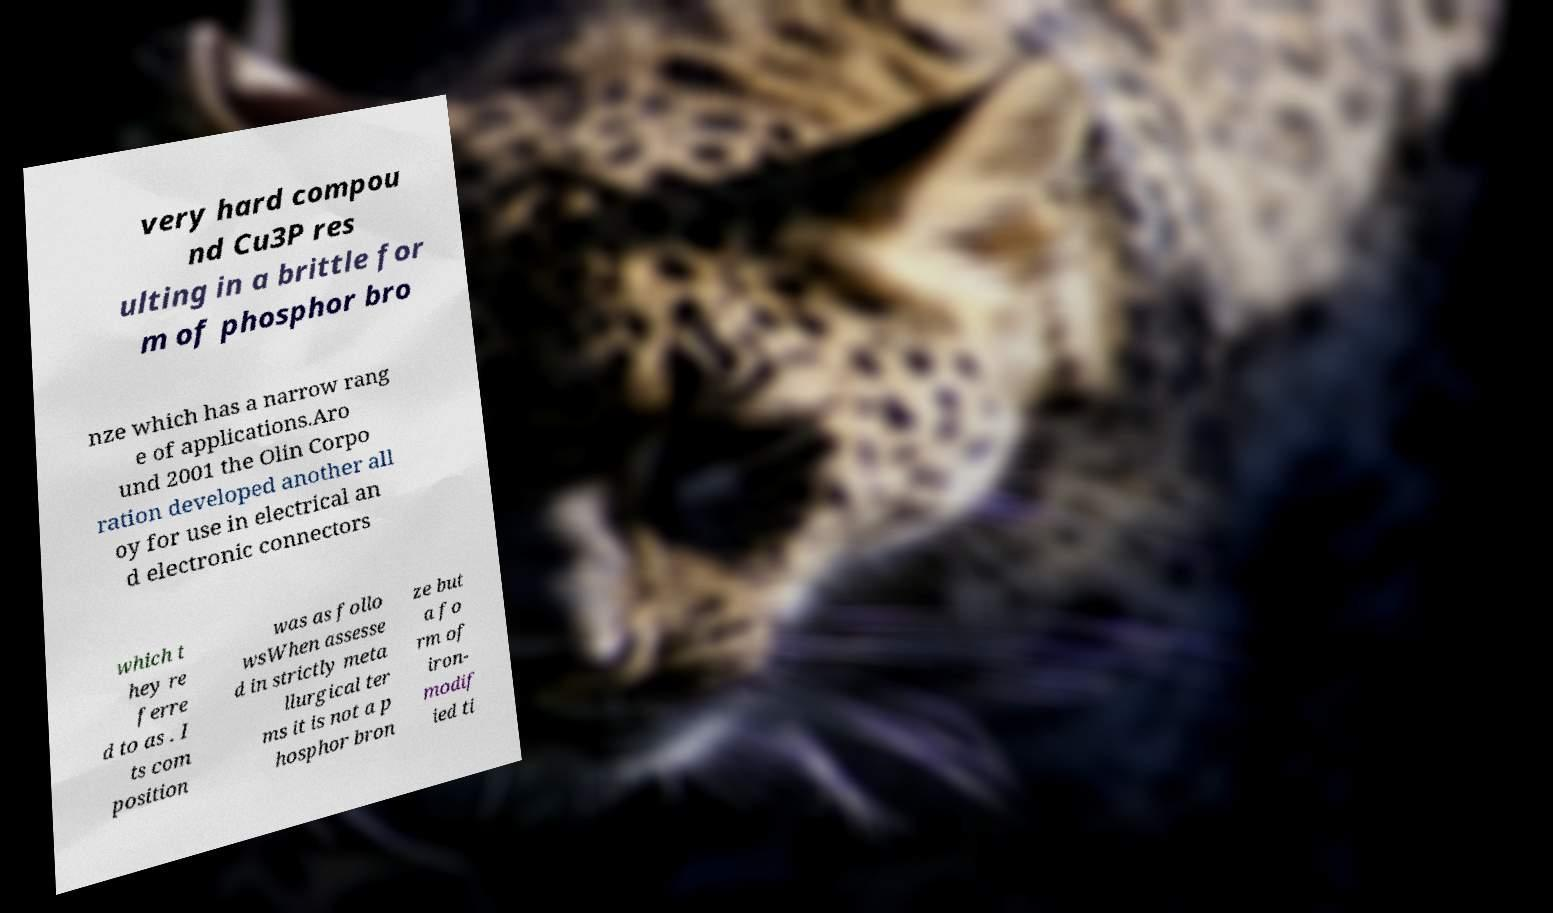Please read and relay the text visible in this image. What does it say? very hard compou nd Cu3P res ulting in a brittle for m of phosphor bro nze which has a narrow rang e of applications.Aro und 2001 the Olin Corpo ration developed another all oy for use in electrical an d electronic connectors which t hey re ferre d to as . I ts com position was as follo wsWhen assesse d in strictly meta llurgical ter ms it is not a p hosphor bron ze but a fo rm of iron- modif ied ti 